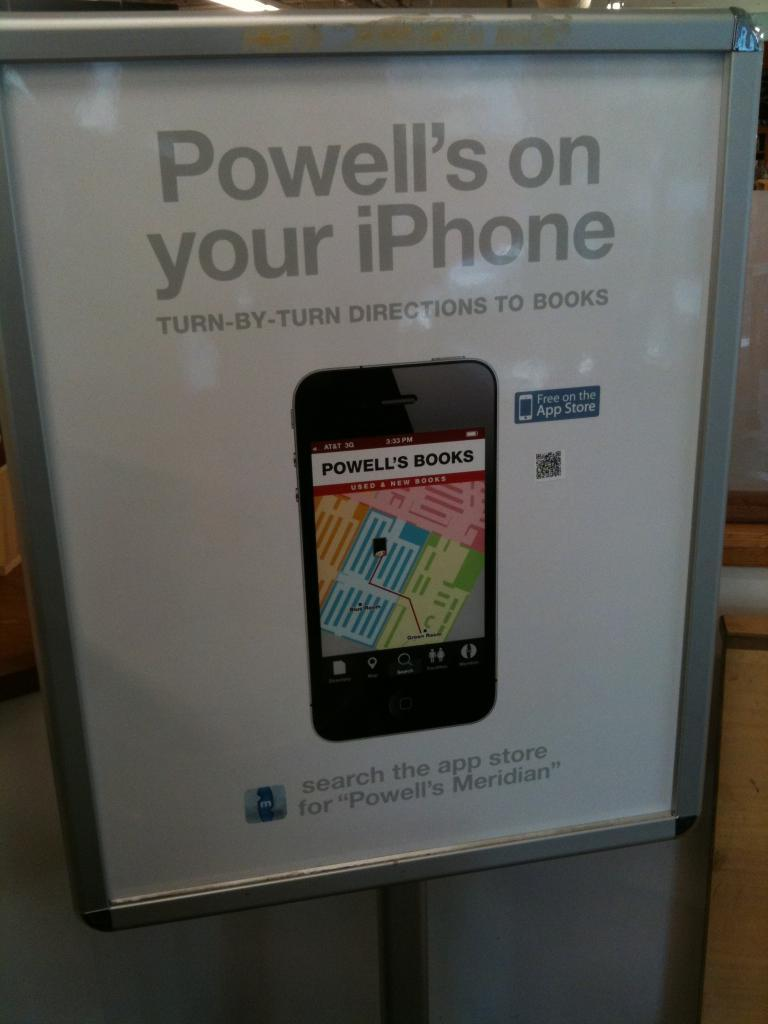<image>
Write a terse but informative summary of the picture. an ad that says Powell's on your iPhone for a directions app 